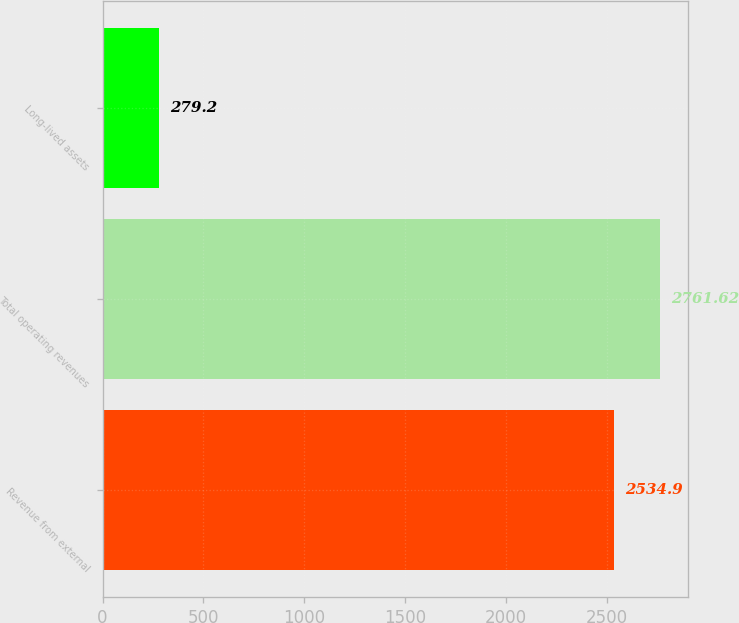Convert chart to OTSL. <chart><loc_0><loc_0><loc_500><loc_500><bar_chart><fcel>Revenue from external<fcel>Total operating revenues<fcel>Long-lived assets<nl><fcel>2534.9<fcel>2761.62<fcel>279.2<nl></chart> 